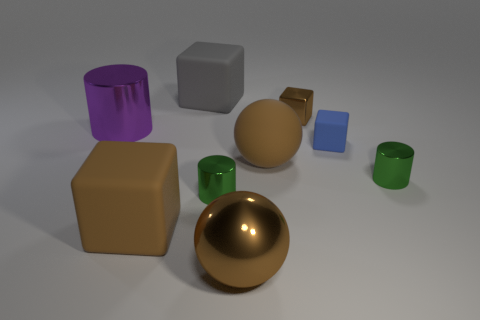What shape is the large brown metal thing?
Your answer should be very brief. Sphere. There is a small object that is behind the large cylinder; is there a metal cylinder on the left side of it?
Your answer should be very brief. Yes. What material is the purple cylinder that is the same size as the gray matte object?
Your answer should be very brief. Metal. Is there a cylinder that has the same size as the blue rubber cube?
Make the answer very short. Yes. What is the green object that is to the right of the small blue object made of?
Your response must be concise. Metal. Does the large thing behind the big metallic cylinder have the same material as the large cylinder?
Keep it short and to the point. No. The gray matte thing that is the same size as the brown rubber ball is what shape?
Offer a very short reply. Cube. What number of big things are the same color as the large cylinder?
Your response must be concise. 0. Are there fewer large brown rubber objects on the right side of the tiny rubber thing than metal objects that are to the right of the big metal ball?
Offer a very short reply. Yes. Are there any cylinders left of the brown rubber sphere?
Keep it short and to the point. Yes. 